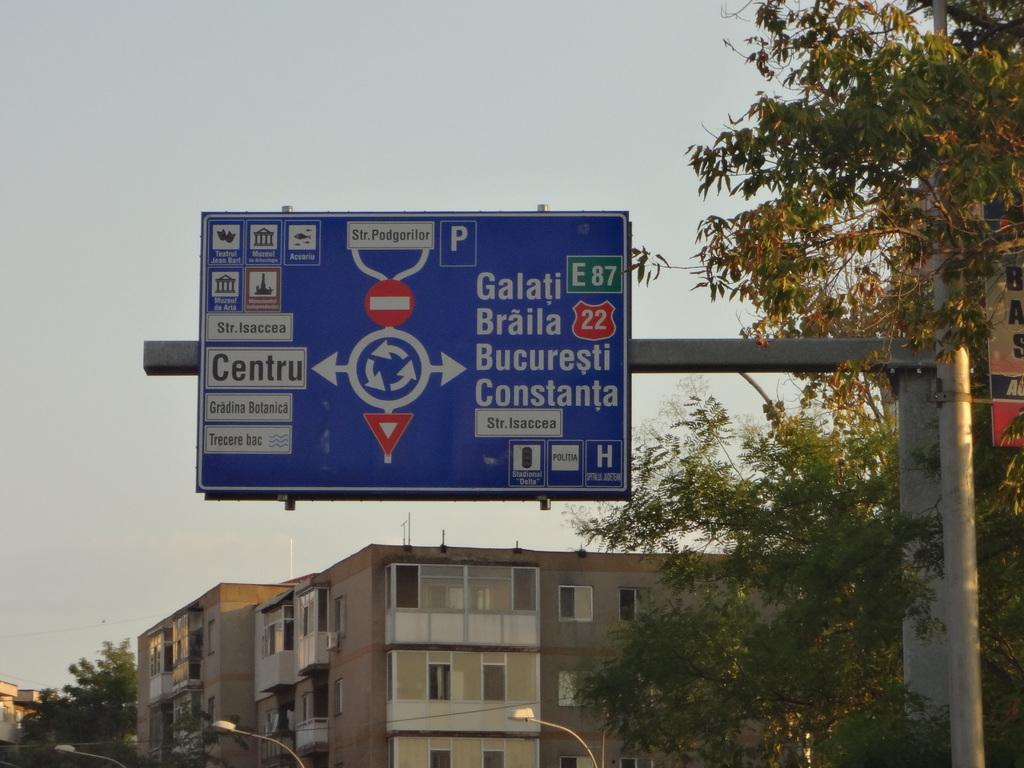<image>
Present a compact description of the photo's key features. A blue street sign that is written in a foreign language and says Galati E87 on it. 